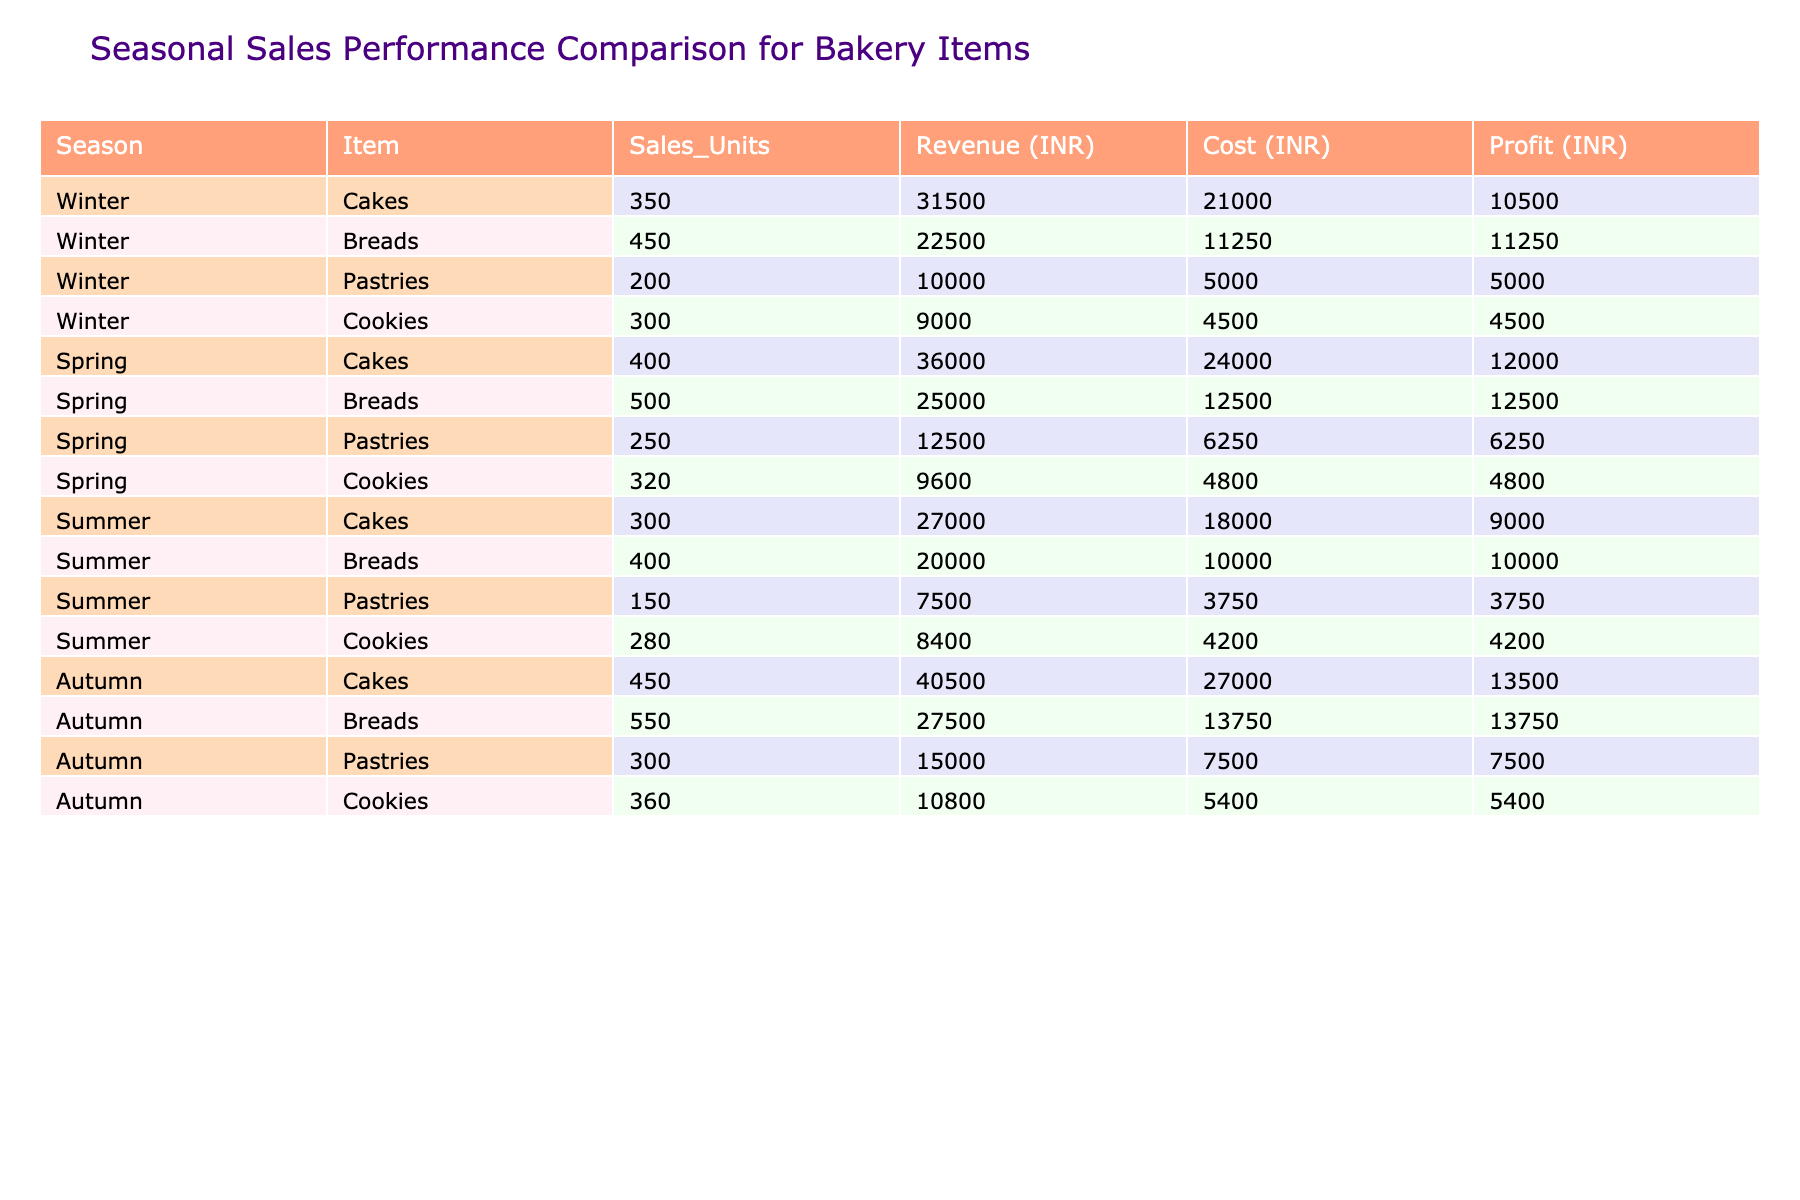What is the total revenue generated from cookie sales during Summer? In Summer, cookies sold 280 units generating a revenue of 8400 INR. Therefore, the total revenue from cookie sales during Summer is 8400 INR.
Answer: 8400 INR Which season had the highest profit for cake sales? Autumn had the highest profit for cake sales, with a profit of 13500 INR compared to other seasons: Winter (10500 INR), Spring (12000 INR), and Summer (9000 INR).
Answer: Autumn What is the average number of sales units for pastries across all seasons? For pastries, the sales units are: Winter (200), Spring (250), Summer (150), and Autumn (300). The total is 200 + 250 + 150 + 300 = 900. Dividing by the number of seasons (4), the average is 900 / 4 = 225.
Answer: 225 Did breads generate more revenue in Winter than in Summer? In Winter, breads generated 22500 INR, while in Summer, they generated 20000 INR. Since 22500 INR is greater than 20000 INR, the statement is true.
Answer: Yes Which item had the biggest increase in sales units from Winter to Spring? The sales units for cakes increased from Winter (350) to Spring (400), resulting in an increase of 50. For breads, the increase is 100 (from 450 to 500). For pastries, the increase is 50 (from 200 to 250), and for cookies, the increase is 20 (from 300 to 320). The biggest increase was in breads.
Answer: Breads What is the total profit for the Autumn season? The profit for Autumn items is: Cakes (13500), Breads (13750), Pastries (7500), and Cookies (5400). Adding them gives: 13500 + 13750 + 7500 + 5400 = 40000.
Answer: 40000 INR Which item had the lowest sales units overall across all seasons? The sales units for pastries are: Winter (200), Spring (250), Summer (150), and Autumn (300). The lowest is 150 in Summer. Comparing with other items, pastries had the lowest sales units overall.
Answer: Pastries What percentage of total revenue did cookie sales represent in Spring? The total revenue for Spring is: Cakes (36000), Breads (25000), Pastries (12500), and Cookies (9600). The total is 36000 + 25000 + 12500 + 9600 = 83100. Cookie revenue is 9600. Therefore, the percentage is (9600 / 83100) * 100 = 11.55%.
Answer: 11.55% Which season had the total lowest sales units combined across all items? Summer had sales units: Cakes (300), Breads (400), Pastries (150), and Cookies (280), for a total of 300 + 400 + 150 + 280 = 1130. Comparatively, Winter has (350+450+200+300=1350), Spring (400+500+250+320=1470), and Autumn (450+550+300+360=1710). Therefore, Summer had the lowest sales units combined.
Answer: Summer Is the total profit for breads higher than the total profit for pastries in Winter? In Winter, breads generated a profit of 11250 INR, while pastries generated a profit of 5000 INR. Since 11250 is greater than 5000, the statement is true.
Answer: Yes 